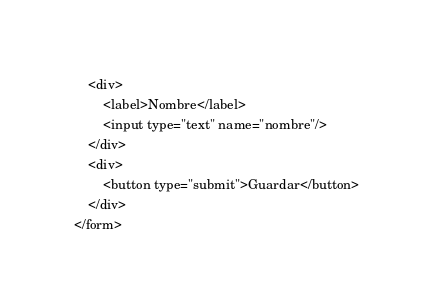<code> <loc_0><loc_0><loc_500><loc_500><_PHP_>	<div>
		<label>Nombre</label>
		<input type="text" name="nombre"/>
	</div>
	<div>
		<button type="submit">Guardar</button>
	</div>
</form></code> 